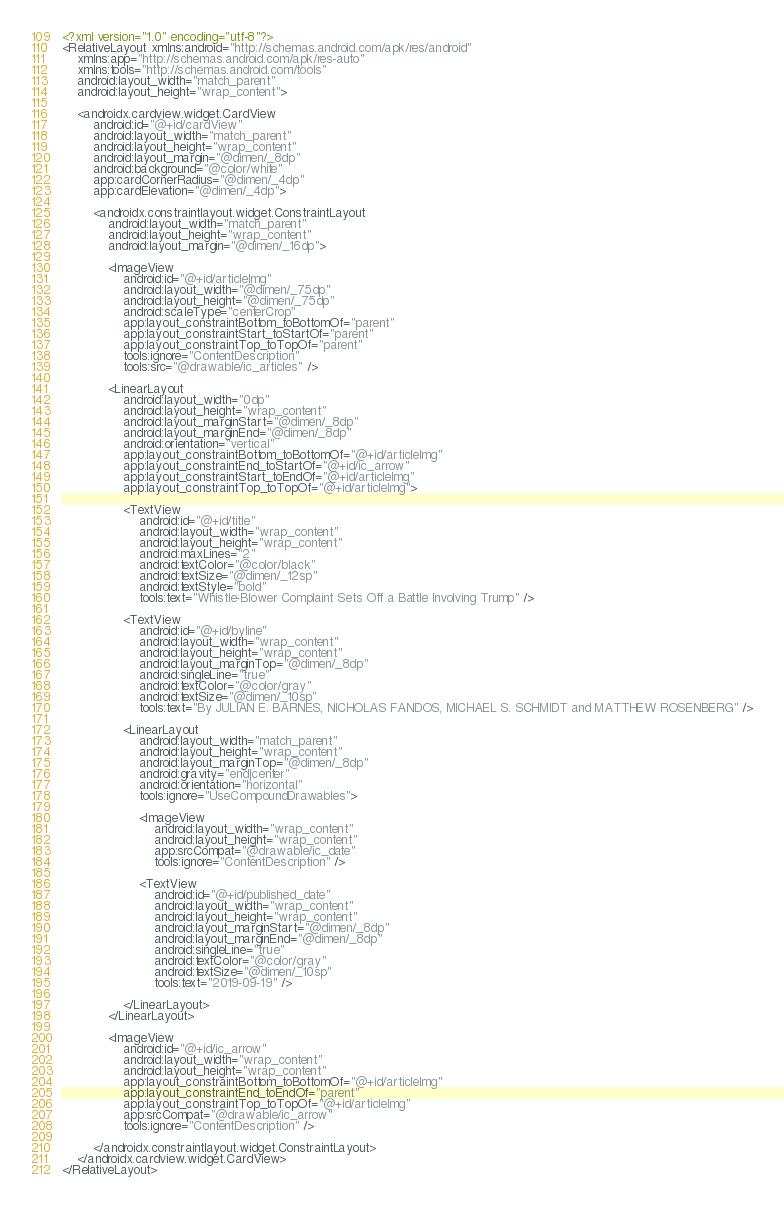Convert code to text. <code><loc_0><loc_0><loc_500><loc_500><_XML_><?xml version="1.0" encoding="utf-8"?>
<RelativeLayout xmlns:android="http://schemas.android.com/apk/res/android"
    xmlns:app="http://schemas.android.com/apk/res-auto"
    xmlns:tools="http://schemas.android.com/tools"
    android:layout_width="match_parent"
    android:layout_height="wrap_content">

    <androidx.cardview.widget.CardView
        android:id="@+id/cardView"
        android:layout_width="match_parent"
        android:layout_height="wrap_content"
        android:layout_margin="@dimen/_8dp"
        android:background="@color/white"
        app:cardCornerRadius="@dimen/_4dp"
        app:cardElevation="@dimen/_4dp">

        <androidx.constraintlayout.widget.ConstraintLayout
            android:layout_width="match_parent"
            android:layout_height="wrap_content"
            android:layout_margin="@dimen/_16dp">

            <ImageView
                android:id="@+id/articleImg"
                android:layout_width="@dimen/_75dp"
                android:layout_height="@dimen/_75dp"
                android:scaleType="centerCrop"
                app:layout_constraintBottom_toBottomOf="parent"
                app:layout_constraintStart_toStartOf="parent"
                app:layout_constraintTop_toTopOf="parent"
                tools:ignore="ContentDescription"
                tools:src="@drawable/ic_articles" />

            <LinearLayout
                android:layout_width="0dp"
                android:layout_height="wrap_content"
                android:layout_marginStart="@dimen/_8dp"
                android:layout_marginEnd="@dimen/_8dp"
                android:orientation="vertical"
                app:layout_constraintBottom_toBottomOf="@+id/articleImg"
                app:layout_constraintEnd_toStartOf="@+id/ic_arrow"
                app:layout_constraintStart_toEndOf="@+id/articleImg"
                app:layout_constraintTop_toTopOf="@+id/articleImg">

                <TextView
                    android:id="@+id/title"
                    android:layout_width="wrap_content"
                    android:layout_height="wrap_content"
                    android:maxLines="2"
                    android:textColor="@color/black"
                    android:textSize="@dimen/_12sp"
                    android:textStyle="bold"
                    tools:text="Whistle-Blower Complaint Sets Off a Battle Involving Trump" />

                <TextView
                    android:id="@+id/byline"
                    android:layout_width="wrap_content"
                    android:layout_height="wrap_content"
                    android:layout_marginTop="@dimen/_8dp"
                    android:singleLine="true"
                    android:textColor="@color/gray"
                    android:textSize="@dimen/_10sp"
                    tools:text="By JULIAN E. BARNES, NICHOLAS FANDOS, MICHAEL S. SCHMIDT and MATTHEW ROSENBERG" />

                <LinearLayout
                    android:layout_width="match_parent"
                    android:layout_height="wrap_content"
                    android:layout_marginTop="@dimen/_8dp"
                    android:gravity="end|center"
                    android:orientation="horizontal"
                    tools:ignore="UseCompoundDrawables">

                    <ImageView
                        android:layout_width="wrap_content"
                        android:layout_height="wrap_content"
                        app:srcCompat="@drawable/ic_date"
                        tools:ignore="ContentDescription" />

                    <TextView
                        android:id="@+id/published_date"
                        android:layout_width="wrap_content"
                        android:layout_height="wrap_content"
                        android:layout_marginStart="@dimen/_8dp"
                        android:layout_marginEnd="@dimen/_8dp"
                        android:singleLine="true"
                        android:textColor="@color/gray"
                        android:textSize="@dimen/_10sp"
                        tools:text="2019-09-19" />

                </LinearLayout>
            </LinearLayout>

            <ImageView
                android:id="@+id/ic_arrow"
                android:layout_width="wrap_content"
                android:layout_height="wrap_content"
                app:layout_constraintBottom_toBottomOf="@+id/articleImg"
                app:layout_constraintEnd_toEndOf="parent"
                app:layout_constraintTop_toTopOf="@+id/articleImg"
                app:srcCompat="@drawable/ic_arrow"
                tools:ignore="ContentDescription" />

        </androidx.constraintlayout.widget.ConstraintLayout>
    </androidx.cardview.widget.CardView>
</RelativeLayout></code> 